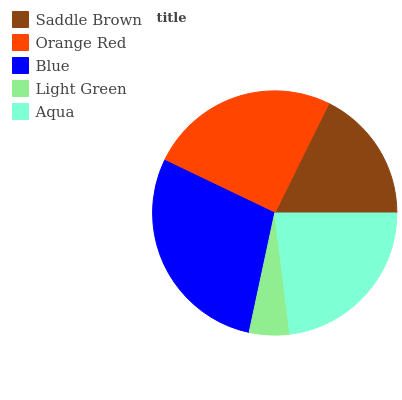Is Light Green the minimum?
Answer yes or no. Yes. Is Blue the maximum?
Answer yes or no. Yes. Is Orange Red the minimum?
Answer yes or no. No. Is Orange Red the maximum?
Answer yes or no. No. Is Orange Red greater than Saddle Brown?
Answer yes or no. Yes. Is Saddle Brown less than Orange Red?
Answer yes or no. Yes. Is Saddle Brown greater than Orange Red?
Answer yes or no. No. Is Orange Red less than Saddle Brown?
Answer yes or no. No. Is Aqua the high median?
Answer yes or no. Yes. Is Aqua the low median?
Answer yes or no. Yes. Is Light Green the high median?
Answer yes or no. No. Is Orange Red the low median?
Answer yes or no. No. 